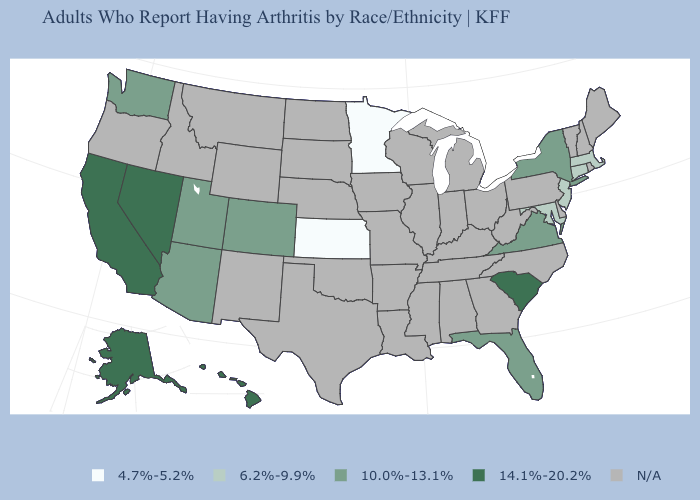How many symbols are there in the legend?
Short answer required. 5. What is the value of Idaho?
Short answer required. N/A. What is the lowest value in the West?
Concise answer only. 10.0%-13.1%. Name the states that have a value in the range 4.7%-5.2%?
Write a very short answer. Kansas, Minnesota. Name the states that have a value in the range 6.2%-9.9%?
Write a very short answer. Connecticut, Maryland, Massachusetts, New Jersey. Name the states that have a value in the range 10.0%-13.1%?
Concise answer only. Arizona, Colorado, Florida, New York, Utah, Virginia, Washington. Name the states that have a value in the range 6.2%-9.9%?
Answer briefly. Connecticut, Maryland, Massachusetts, New Jersey. What is the value of Tennessee?
Answer briefly. N/A. What is the value of Nebraska?
Concise answer only. N/A. What is the value of Indiana?
Be succinct. N/A. Which states have the lowest value in the USA?
Answer briefly. Kansas, Minnesota. What is the value of South Dakota?
Write a very short answer. N/A. Does the map have missing data?
Short answer required. Yes. Name the states that have a value in the range 14.1%-20.2%?
Keep it brief. Alaska, California, Hawaii, Nevada, South Carolina. 